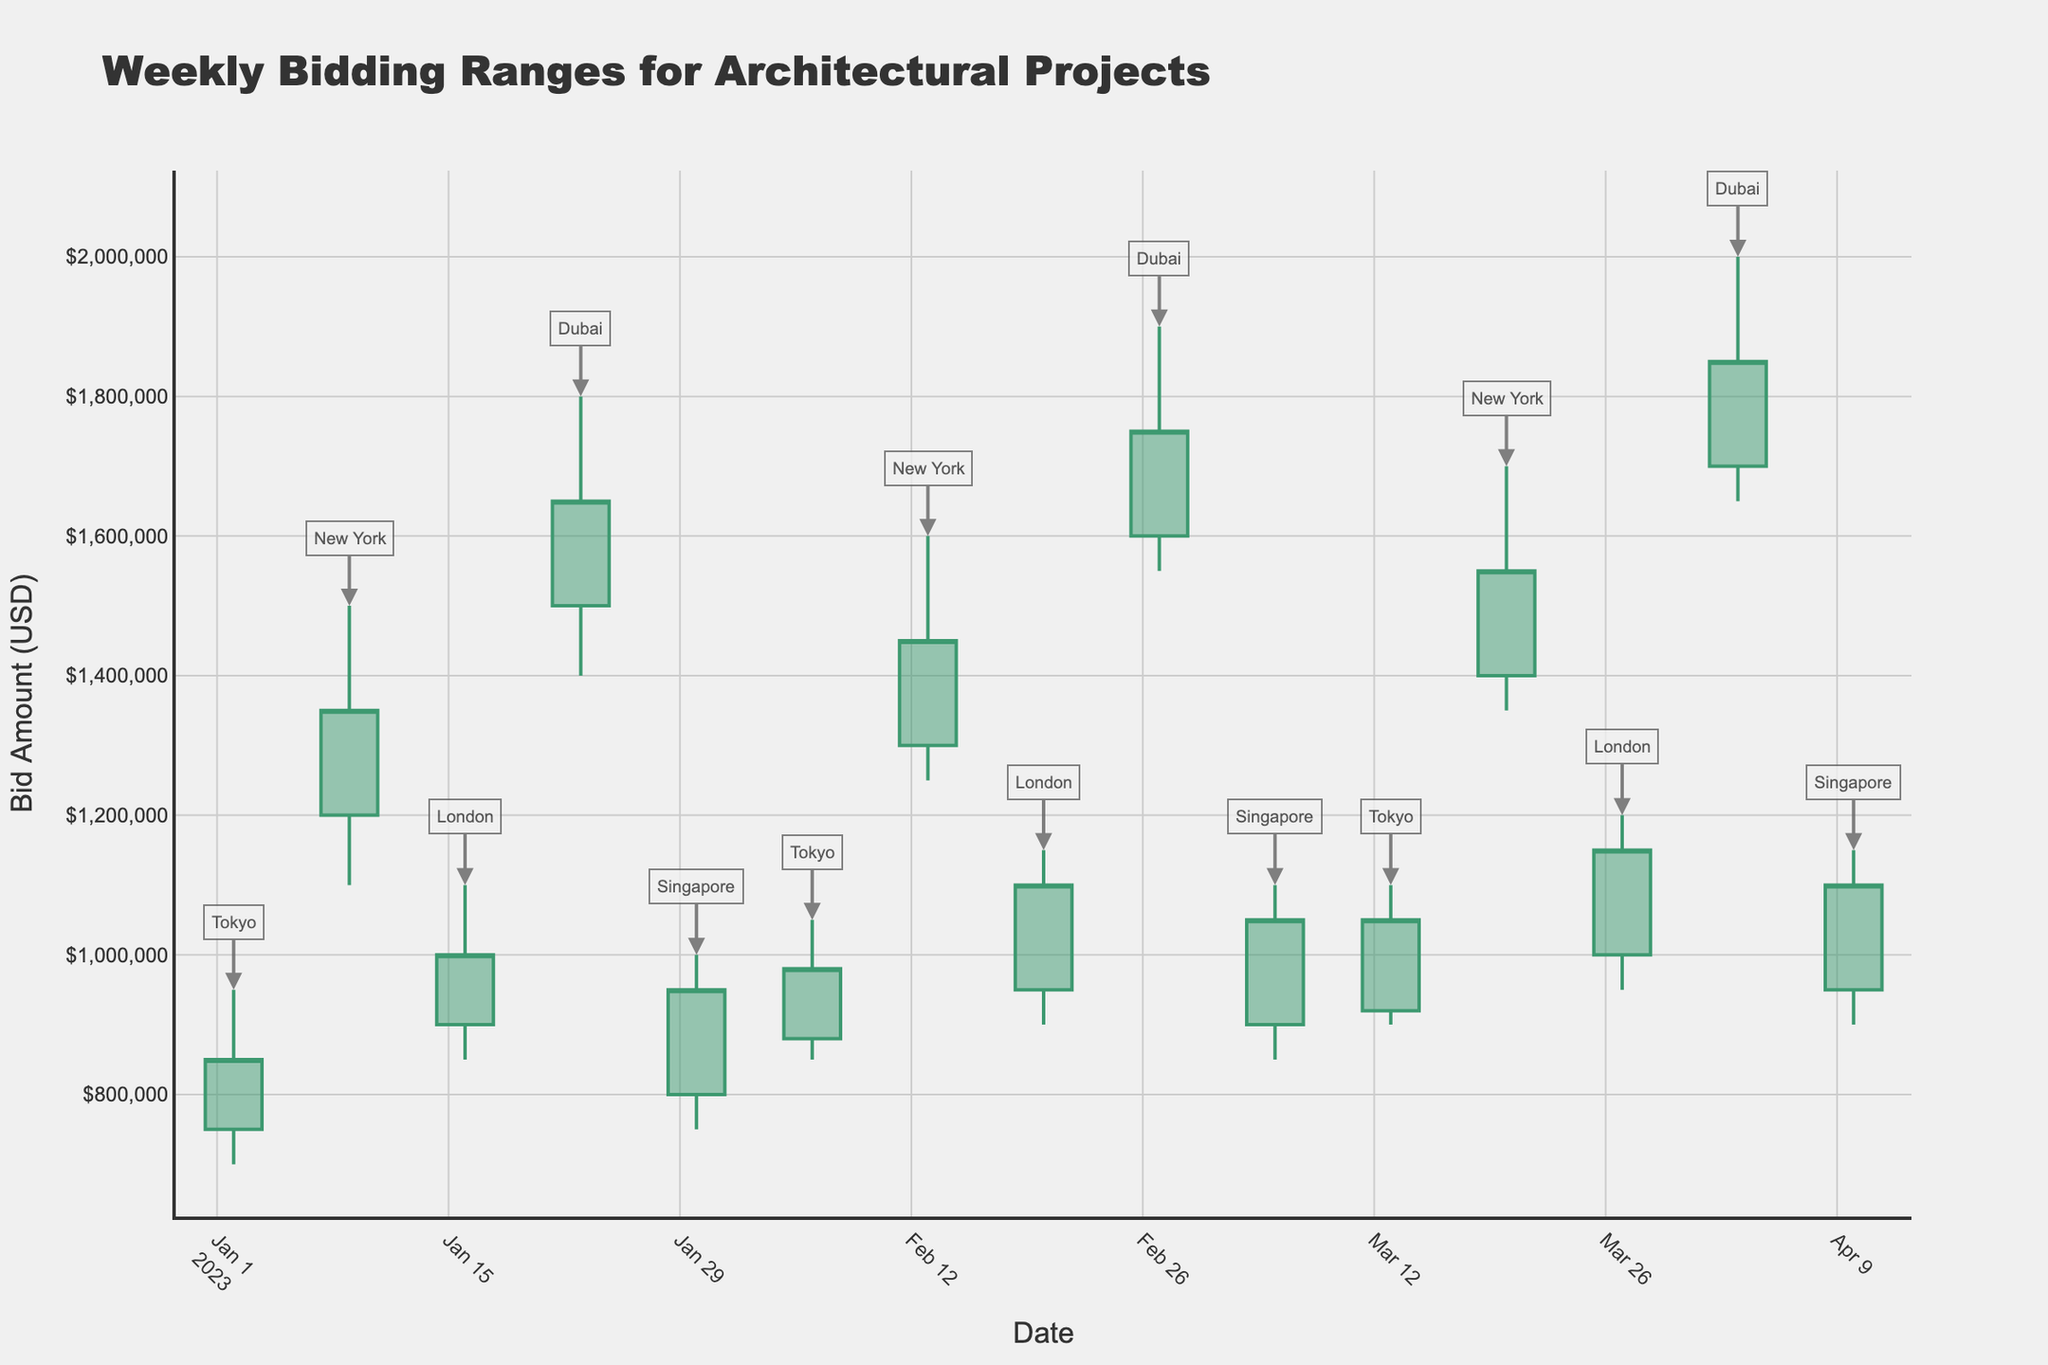What is the title of the chart? The title is displayed at the top of the chart and reads: "Weekly Bidding Ranges for Architectural Projects."
Answer: Weekly Bidding Ranges for Architectural Projects What is the color of the lines for increasing bids? The lines for increasing bids are shown in green color. This is noticeable since these portions of the candlestick lines appear in green color.
Answer: Green Which city had the highest bidding amount in the given time period? The city of Dubai had the highest bidding amount as indicated by their high value of $2,000,000 during the week of 2023-04-03.
Answer: Dubai What are the date ranges shown on the x-axis of the chart? The x-axis displays dates ranging from January 2, 2023, to April 10, 2023.
Answer: January 2, 2023, to April 10, 2023 What was the closing bid for Tokyo on the week starting January 2, 2023? The closing bid for Tokyo for the week starting January 2, 2023, is $850,000, as indicated at the bottom of the candlestick for that date.
Answer: $850,000 By how much did the closing bid in New York increase from the week starting January 9, 2023, to the week starting February 13, 2023? The closing bid in New York on January 9, 2023, was $1,350,000, and by February 13, 2023, it was $1,450,000. The increase is $1,450,000 - $1,350,000 = $100,000.
Answer: $100,000 Which city had the lowest bidding amount overall, and what was that value? The lowest overall bidding amount was in Tokyo, with a low value of $700,000 during the week of January 2, 2023.
Answer: Tokyo, $700,000 Which city's bidding range had no overlapping with other cities during the weeks displayed? Dubai's bidding ranges do not overlap with other cities during the weeks displayed. You can see that Dubai's minimum bid amount is always higher than any other city's maximum bid amount for the same week.
Answer: Dubai What is the closing bid for the week starting March 13, 2023, in Singapore? The closing bid for Singapore for the week starting on March 13, 2023, was $1,050,000, as shown by the bottom of the candlestick for that date.
Answer: $1,050,000 How does the trend in Dubai's bids from January to April 2023 compare with Tokyo's bids in the same period? Dubai's bids show a consistently increasing trend from January to April 2023, while Tokyo's bids also generally increase but have some fluctuation. Dubai's trend was more consistently upward compared to Tokyo's.
Answer: Consistently increasing for Dubai, fluctuating for Tokyo 